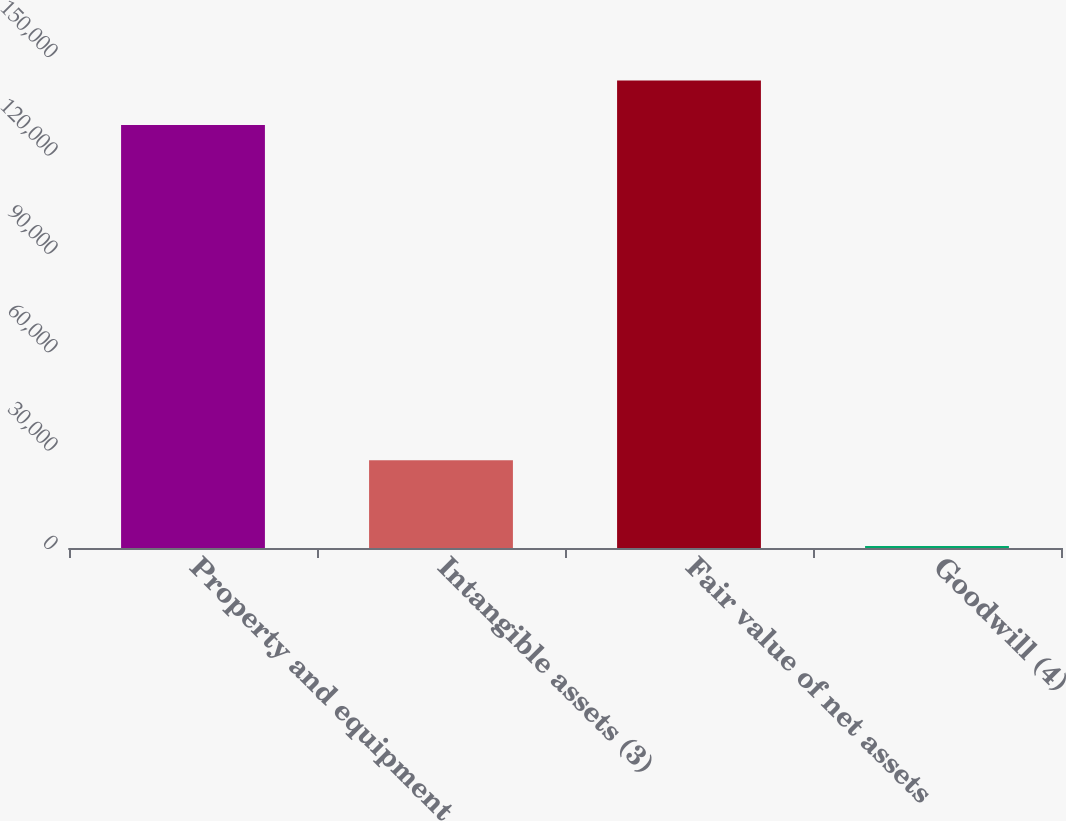<chart> <loc_0><loc_0><loc_500><loc_500><bar_chart><fcel>Property and equipment<fcel>Intangible assets (3)<fcel>Fair value of net assets<fcel>Goodwill (4)<nl><fcel>128989<fcel>26791<fcel>142497<fcel>576<nl></chart> 